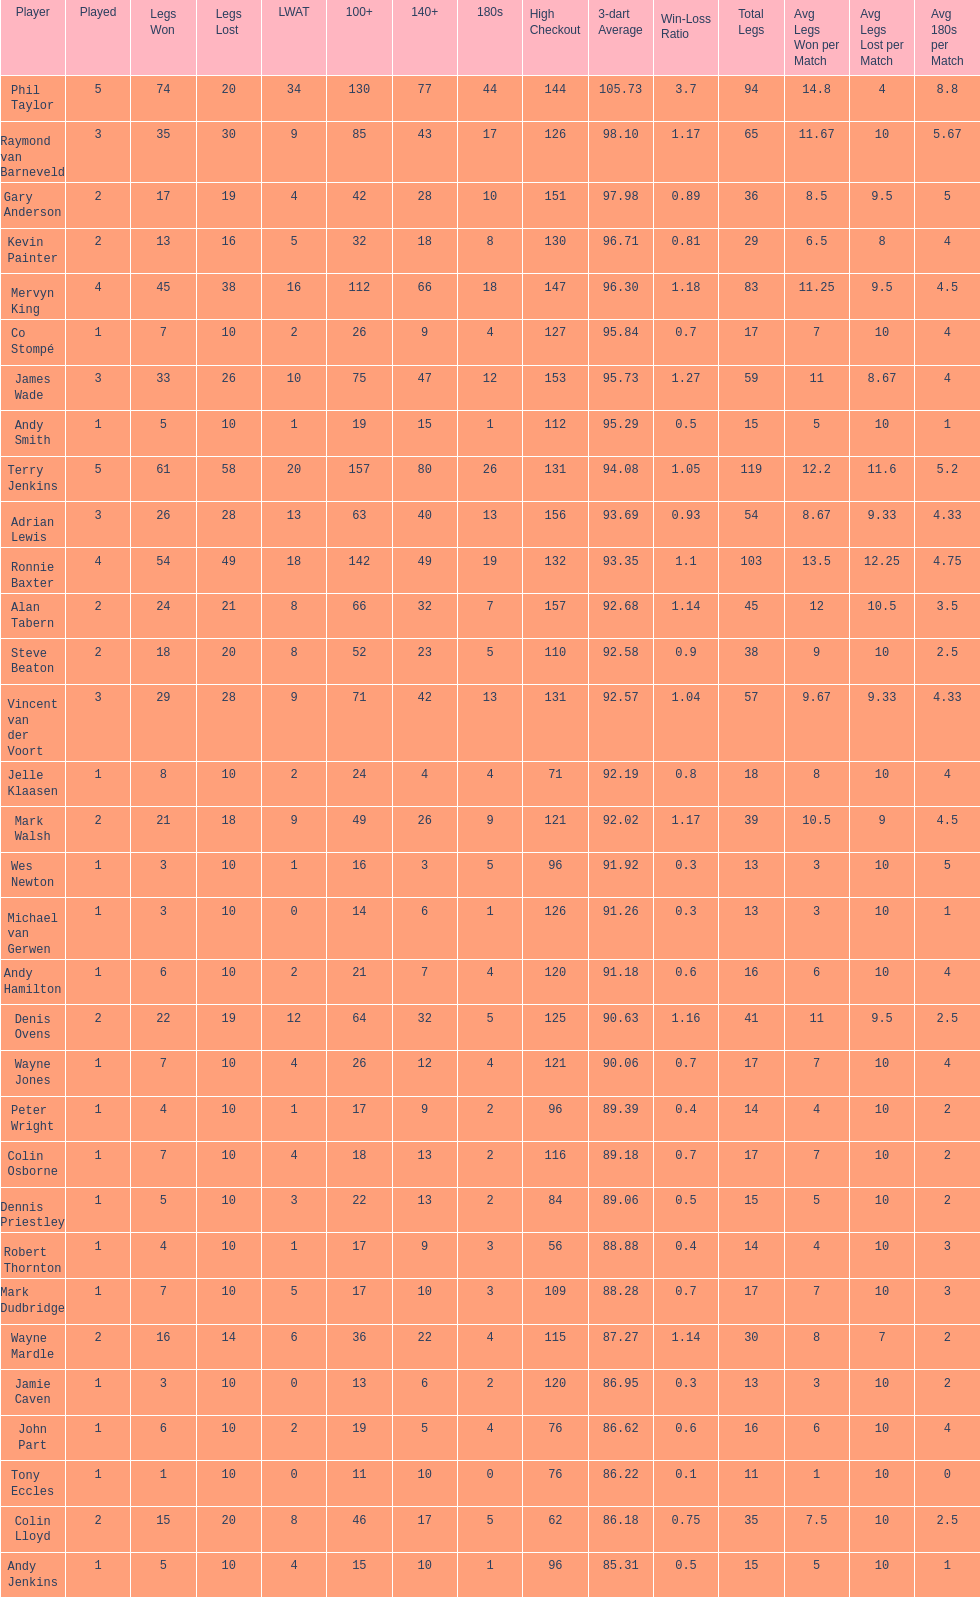Which player lost the least? Co Stompé, Andy Smith, Jelle Klaasen, Wes Newton, Michael van Gerwen, Andy Hamilton, Wayne Jones, Peter Wright, Colin Osborne, Dennis Priestley, Robert Thornton, Mark Dudbridge, Jamie Caven, John Part, Tony Eccles, Andy Jenkins. 